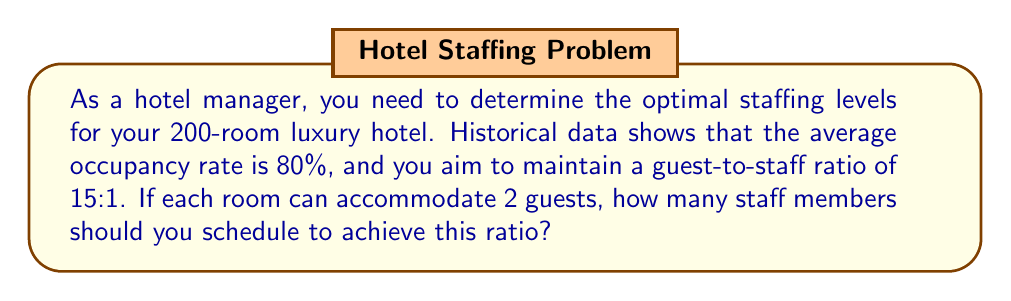Can you answer this question? Let's approach this problem step-by-step:

1) First, calculate the total number of potential guests:
   $$ \text{Total potential guests} = \text{Number of rooms} \times \text{Guests per room} $$
   $$ \text{Total potential guests} = 200 \times 2 = 400 $$

2) Now, calculate the expected number of guests based on the occupancy rate:
   $$ \text{Expected guests} = \text{Total potential guests} \times \text{Occupancy rate} $$
   $$ \text{Expected guests} = 400 \times 0.80 = 320 $$

3) Given the desired guest-to-staff ratio of 15:1, we can set up the following equation:
   $$ \frac{\text{Expected guests}}{\text{Number of staff}} = 15:1 $$

4) Substitute the known value for expected guests:
   $$ \frac{320}{\text{Number of staff}} = 15 $$

5) Solve for the number of staff:
   $$ \text{Number of staff} = \frac{320}{15} = 21.33 $$

6) Since we can't have a fractional number of staff members, we round up to the nearest whole number to ensure we meet or exceed the desired ratio:
   $$ \text{Number of staff} = \lceil 21.33 \rceil = 22 $$
Answer: 22 staff members 